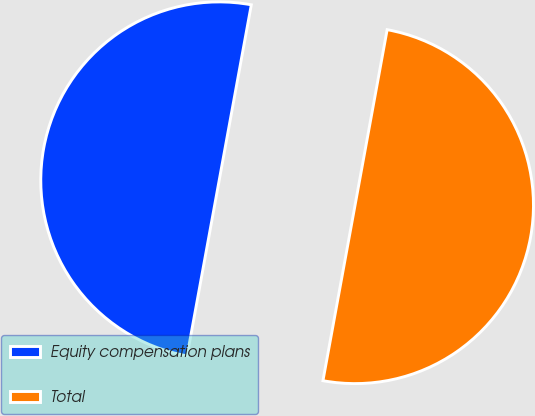Convert chart. <chart><loc_0><loc_0><loc_500><loc_500><pie_chart><fcel>Equity compensation plans<fcel>Total<nl><fcel>50.0%<fcel>50.0%<nl></chart> 